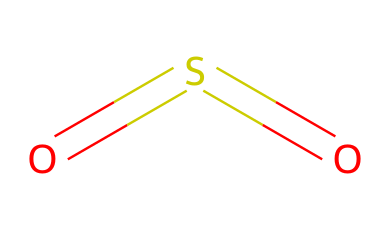How many atoms are in sulfur dioxide? The molecule consists of one sulfur atom and two oxygen atoms, totaling three atoms.
Answer: three What is the molecular shape of sulfur dioxide? The arrangement of the atoms shows a bent molecular shape due to the bond angles resulting from the lone pairs on the oxygen atoms.
Answer: bent How many bonds are present in the sulfur dioxide molecule? The structure shows two double bonds between the sulfur atom and each oxygen atom, resulting in two bonds.
Answer: two What type of pollution is associated with sulfur dioxide? Sulfur dioxide is a common air pollutant, particularly from industrial processes, contributing to acid rain and respiratory problems.
Answer: air pollutant How does the presence of sulfur bonds influence the reactivity of sulfur dioxide? The double bonds between sulfur and oxygen increase the reactivity of the molecule, making it capable of undergoing various chemical reactions such as oxidation.
Answer: increases reactivity What is the oxidation state of sulfur in sulfur dioxide? In sulfur dioxide, sulfur has an oxidation state of +4, calculated based on its bonds with oxygen in the molecular structure.
Answer: +4 What is the primary source of sulfur dioxide production? The primary sources include fossil fuel combustion and industrial processes, particularly in refining and electricity generation.
Answer: fossil fuel combustion 